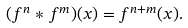<formula> <loc_0><loc_0><loc_500><loc_500>( f ^ { n } * f ^ { m } ) ( x ) = f ^ { n + m } ( x ) .</formula> 